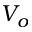<formula> <loc_0><loc_0><loc_500><loc_500>V _ { o }</formula> 